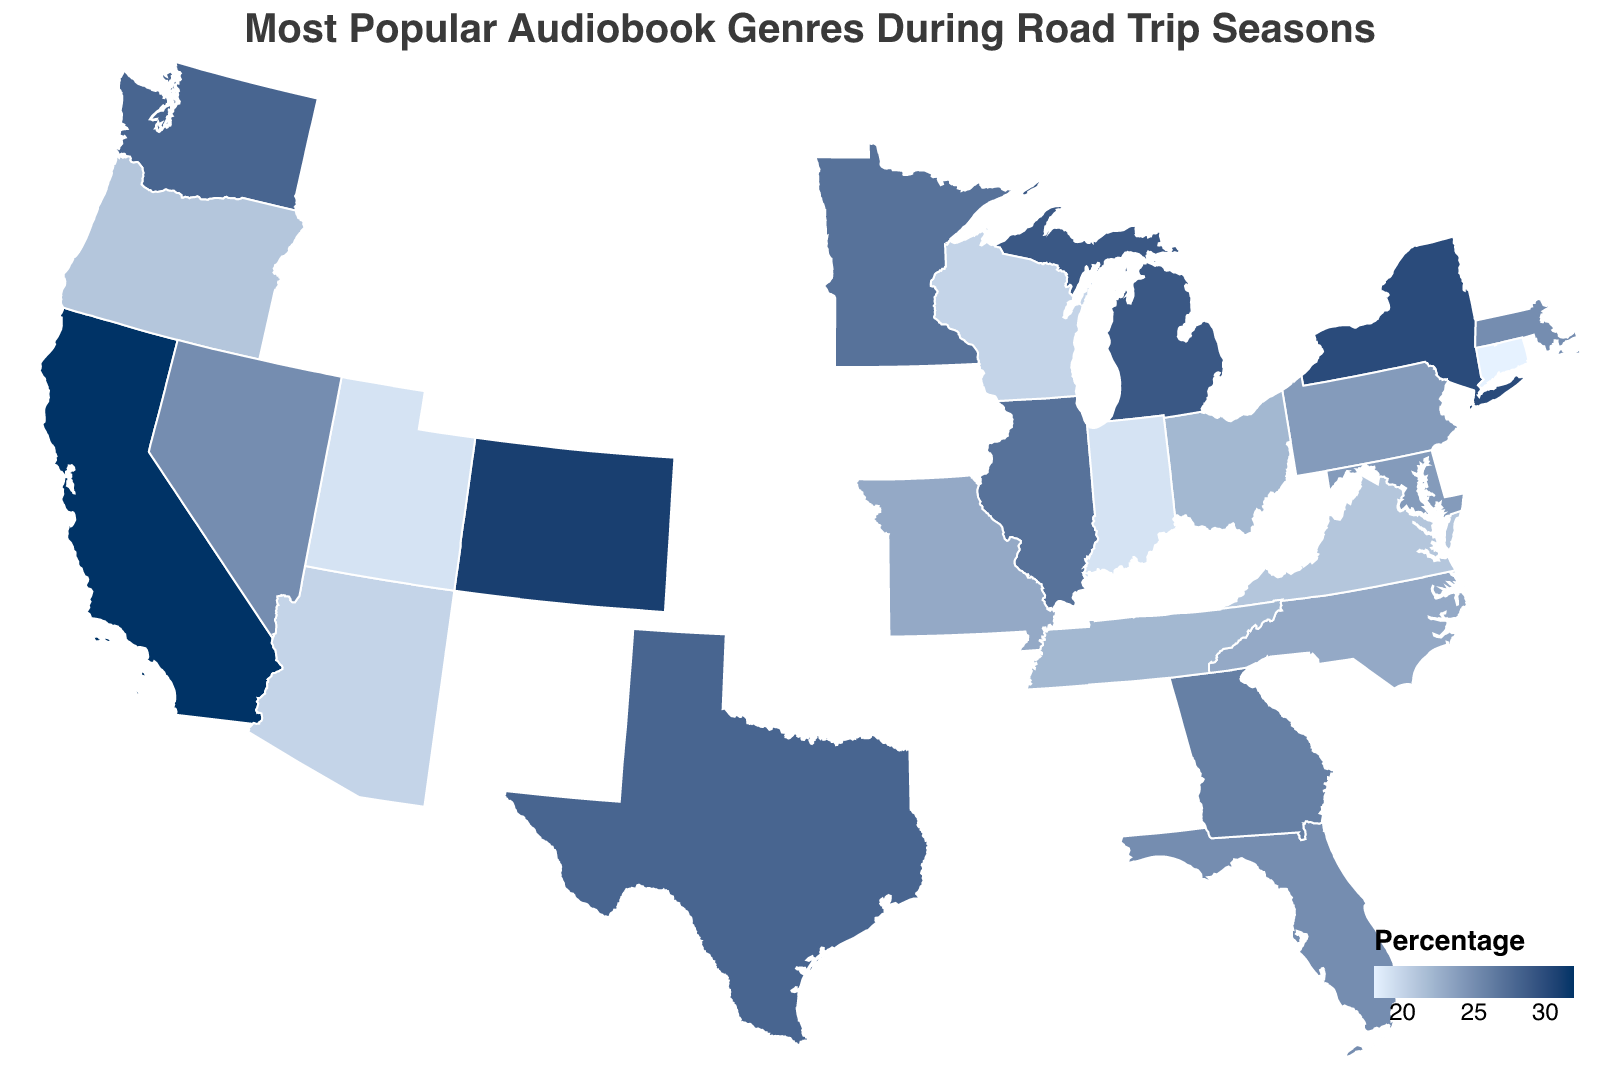What is the most popular audiobook genre in California? Look at the figure, locate California, and observe the label or color associated with it that provides information on the most popular genre.
Answer: Mystery Which state has the highest percentage for its most popular audiobook genre? Review all the states' percentages on the figure and identify the one with the highest value.
Answer: California Compare the popularity of Mystery in California and Adventure in Colorado based on their percentages. Which one is higher? Locate both California and Colorado on the figure, check the percentages for Mystery and Adventure, and compare 32% (California) with 31% (Colorado).
Answer: Mystery in California What is the general trend for the most popular audiobook genre in coastal vs. inland states? Compare the genres listed for coastal states (California, Florida, New York, etc.) and inland states (Illinois, Ohio, Colorado, etc.) by looking at the locations and identifying any common genres or significant differences.
Answer: Trend varies Which states preferred Romance and what are their percentages? Identify the states that have Romance as the most popular audiobook genre by looking at the respective information on the figure and note their percentages.
Answer: Texas (28%) What are the common audiobook genres across the most populated states like California, Texas, and New York? Look at the genres listed for these states and identify if there are any common themes or notable distinctions among them.
Answer: Mystery, Romance, Literary Fiction Determine if there is any state where a percentage for a preferred genre is below 20%. If so, which one? Review the figure for all states' percentages to check if any fall below 20%.
Answer: Yes, Connecticut (18%) What's the least favored audiobook genre with the lowest percentage noted on the map, and which state it belongs to? Identify the genre and state with the minimum percentage by scanning the data points on the figure.
Answer: Poetry, Connecticut (18%) Is there any pattern in audiobook genre preferences geographically (e.g., North vs. South, East vs. West)? Analyze the genres from different regions (North, South, East, West) to observe if there are discernible patterns or similarities in preferences.
Answer: Varied, no clear patterns On average, are states more inclined towards Fiction or Non-Fiction audiobook genres? Identify and count the states with Fiction-related genres vs. those with Non-Fiction-related genres and compare to discern the general inclination.
Answer: Fiction 